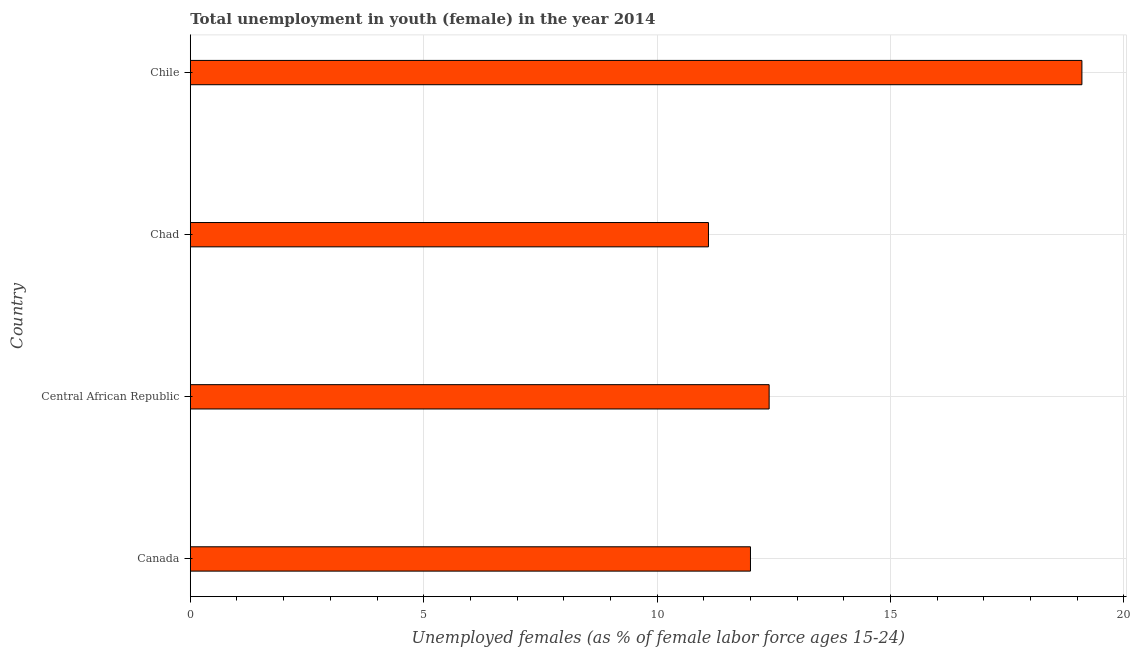Does the graph contain any zero values?
Provide a short and direct response. No. Does the graph contain grids?
Ensure brevity in your answer.  Yes. What is the title of the graph?
Keep it short and to the point. Total unemployment in youth (female) in the year 2014. What is the label or title of the X-axis?
Provide a short and direct response. Unemployed females (as % of female labor force ages 15-24). What is the unemployed female youth population in Canada?
Provide a short and direct response. 12. Across all countries, what is the maximum unemployed female youth population?
Your answer should be very brief. 19.1. Across all countries, what is the minimum unemployed female youth population?
Provide a succinct answer. 11.1. In which country was the unemployed female youth population maximum?
Make the answer very short. Chile. In which country was the unemployed female youth population minimum?
Your answer should be compact. Chad. What is the sum of the unemployed female youth population?
Make the answer very short. 54.6. What is the average unemployed female youth population per country?
Offer a very short reply. 13.65. What is the median unemployed female youth population?
Offer a very short reply. 12.2. In how many countries, is the unemployed female youth population greater than 9 %?
Give a very brief answer. 4. What is the ratio of the unemployed female youth population in Canada to that in Chad?
Offer a very short reply. 1.08. Is the unemployed female youth population in Canada less than that in Chile?
Offer a very short reply. Yes. What is the difference between the highest and the second highest unemployed female youth population?
Your answer should be compact. 6.7. Is the sum of the unemployed female youth population in Central African Republic and Chad greater than the maximum unemployed female youth population across all countries?
Your answer should be very brief. Yes. What is the difference between the highest and the lowest unemployed female youth population?
Provide a succinct answer. 8. Are all the bars in the graph horizontal?
Provide a succinct answer. Yes. How many countries are there in the graph?
Your answer should be very brief. 4. What is the Unemployed females (as % of female labor force ages 15-24) in Central African Republic?
Provide a short and direct response. 12.4. What is the Unemployed females (as % of female labor force ages 15-24) in Chad?
Provide a succinct answer. 11.1. What is the Unemployed females (as % of female labor force ages 15-24) in Chile?
Keep it short and to the point. 19.1. What is the difference between the Unemployed females (as % of female labor force ages 15-24) in Canada and Chile?
Your answer should be compact. -7.1. What is the difference between the Unemployed females (as % of female labor force ages 15-24) in Central African Republic and Chad?
Offer a terse response. 1.3. What is the ratio of the Unemployed females (as % of female labor force ages 15-24) in Canada to that in Central African Republic?
Provide a short and direct response. 0.97. What is the ratio of the Unemployed females (as % of female labor force ages 15-24) in Canada to that in Chad?
Make the answer very short. 1.08. What is the ratio of the Unemployed females (as % of female labor force ages 15-24) in Canada to that in Chile?
Ensure brevity in your answer.  0.63. What is the ratio of the Unemployed females (as % of female labor force ages 15-24) in Central African Republic to that in Chad?
Make the answer very short. 1.12. What is the ratio of the Unemployed females (as % of female labor force ages 15-24) in Central African Republic to that in Chile?
Your answer should be very brief. 0.65. What is the ratio of the Unemployed females (as % of female labor force ages 15-24) in Chad to that in Chile?
Ensure brevity in your answer.  0.58. 